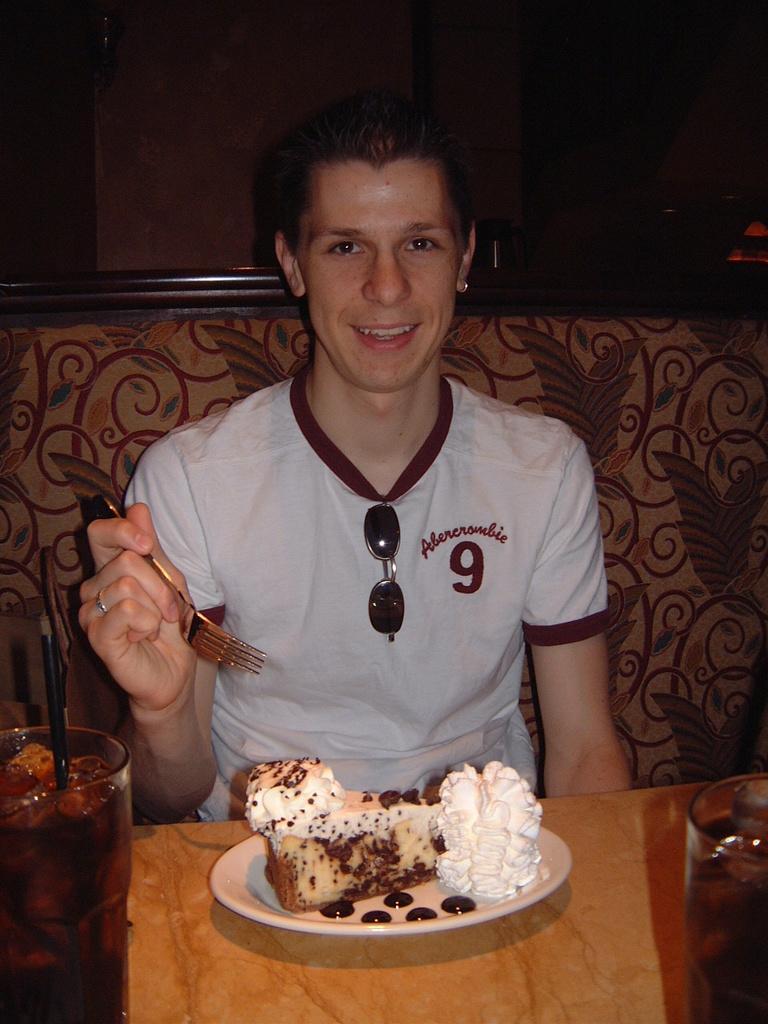In one or two sentences, can you explain what this image depicts? In the image we can see a man wearing clothes, finger ring and the man is smiling, and the man is holding a fork in the hand. Here we can see the wooden surface and on it we can see glasses and the plate, we can even see food on the plate. The background is dark. 